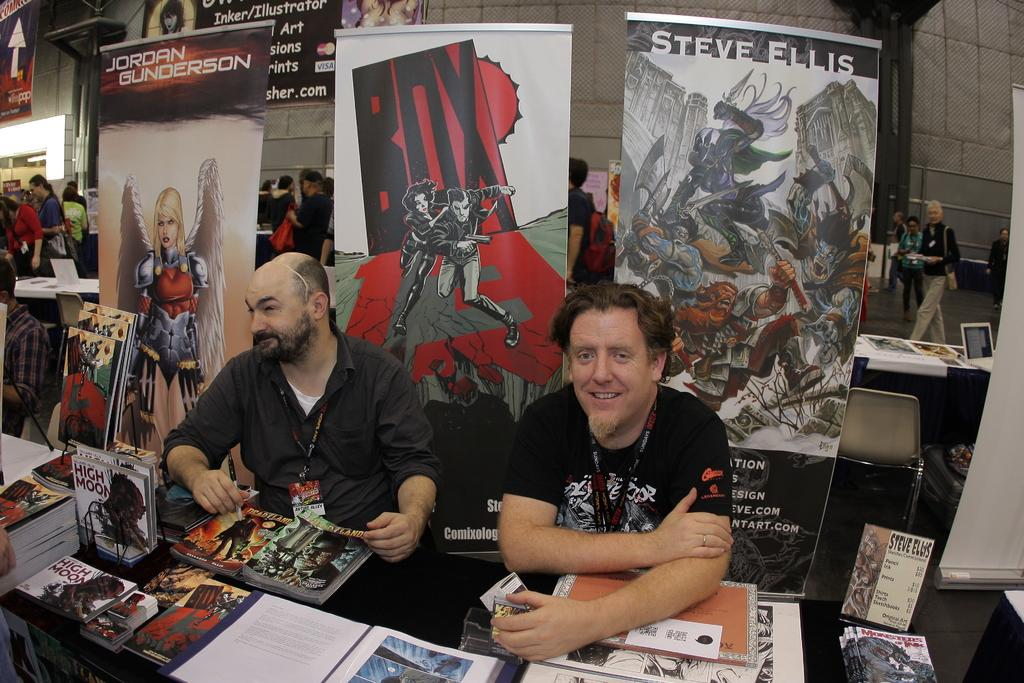<image>
Write a terse but informative summary of the picture. Two men at a table behind the one on the right is a poster topped with the name: Steve Ellis. 